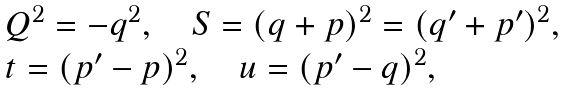<formula> <loc_0><loc_0><loc_500><loc_500>\begin{array} { l l } Q ^ { 2 } = - q ^ { 2 } , \quad S = ( q + p ) ^ { 2 } = ( { q ^ { \prime } } + { p ^ { \prime } } ) ^ { 2 } , \\ t = ( { p ^ { \prime } } - p ) ^ { 2 } , \quad u = ( { p ^ { \prime } } - q ) ^ { 2 } , \end{array}</formula> 